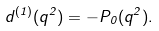Convert formula to latex. <formula><loc_0><loc_0><loc_500><loc_500>d ^ { ( 1 ) } ( q ^ { 2 } ) = - P _ { 0 } ( q ^ { 2 } ) .</formula> 